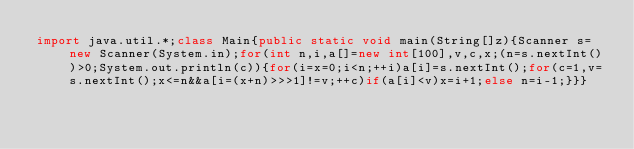<code> <loc_0><loc_0><loc_500><loc_500><_Java_>import java.util.*;class Main{public static void main(String[]z){Scanner s=new Scanner(System.in);for(int n,i,a[]=new int[100],v,c,x;(n=s.nextInt())>0;System.out.println(c)){for(i=x=0;i<n;++i)a[i]=s.nextInt();for(c=1,v=s.nextInt();x<=n&&a[i=(x+n)>>>1]!=v;++c)if(a[i]<v)x=i+1;else n=i-1;}}}</code> 